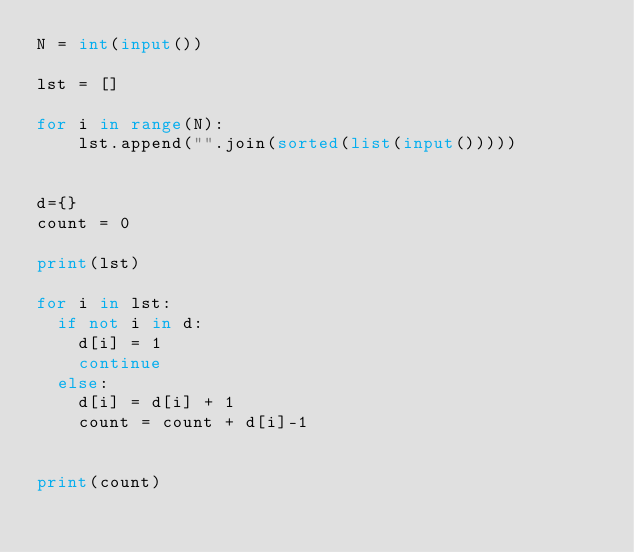Convert code to text. <code><loc_0><loc_0><loc_500><loc_500><_Python_>N = int(input())

lst = []

for i in range(N):
    lst.append("".join(sorted(list(input()))))


d={}
count = 0

print(lst)

for i in lst:
  if not i in d:
    d[i] = 1
    continue
  else:
    d[i] = d[i] + 1
    count = count + d[i]-1


print(count)
</code> 